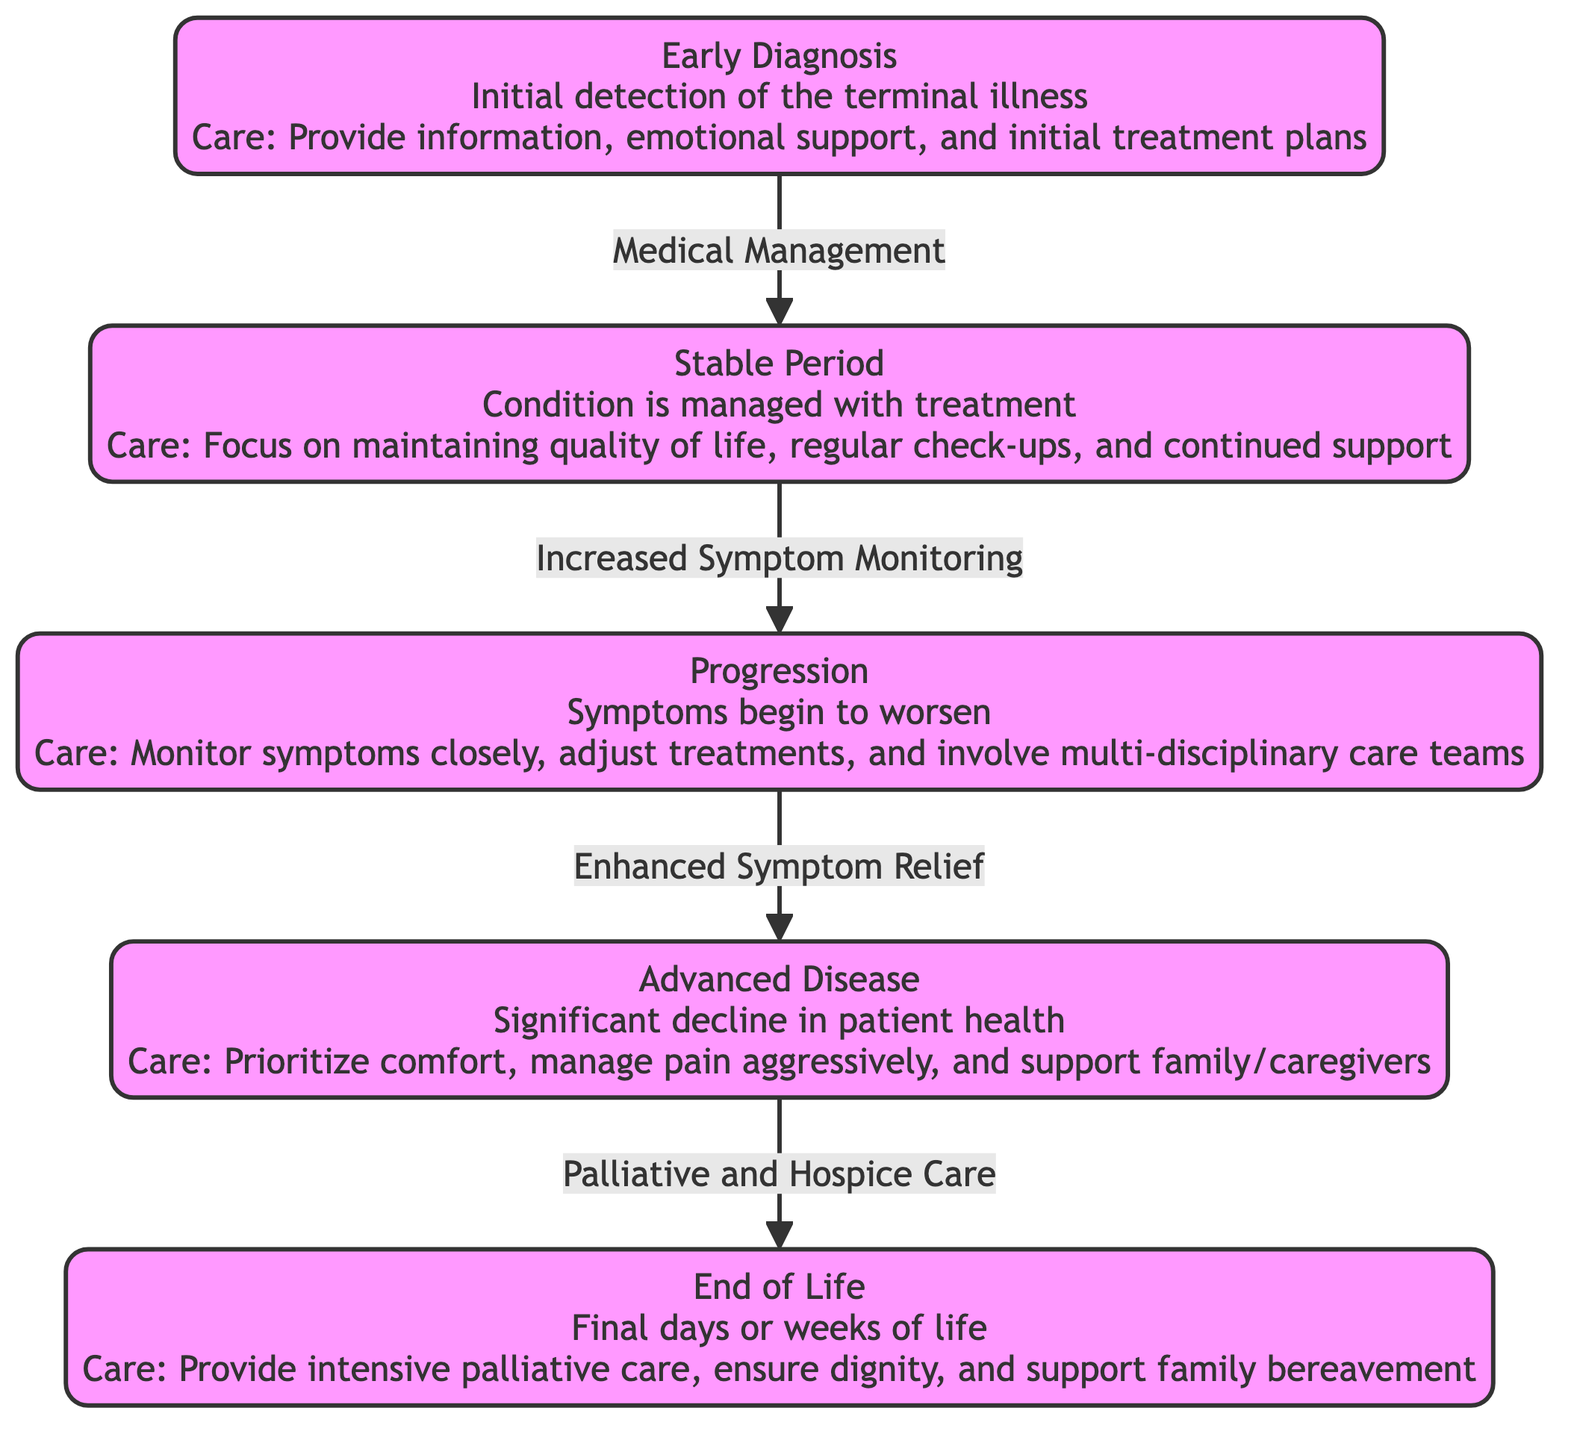What is the first stage in the disease progression timeline? The diagram clearly shows that the first stage is labeled as "Early Diagnosis," which is the initial detection of the terminal illness.
Answer: Early Diagnosis How many stages are presented in the diagram? By counting the distinct stages in the diagram, there are five stages: Early Diagnosis, Stable Period, Progression, Advanced Disease, and End of Life.
Answer: 5 What type of care is provided during the Advanced Disease stage? The diagram specifies that during the Advanced Disease stage, the care focuses on prioritizing comfort and managing pain aggressively.
Answer: Prioritize comfort, manage pain aggressively What is the relationship between the Stable Period and the Progression stage? The diagram indicates a transition from Stable Period to Progression marked by "Increased Symptom Monitoring," which implies that as symptoms are monitored more closely, the patient may enter the Progression phase.
Answer: Increased Symptom Monitoring What care guidance is provided at the End of Life stage? The diagram details that at the End of Life stage, the care involves providing intensive palliative care, ensuring dignity, and supporting family bereavement.
Answer: Intensive palliative care, ensure dignity, support family bereavement Which stage comes after Progression? The flowchart indicates that the stage following Progression is the Advanced Disease stage, which is a significant decline in patient health.
Answer: Advanced Disease What is the main focus during the Stable Period? According to the diagram, the main focus during the Stable Period is on maintaining quality of life, regular check-ups, and continued support.
Answer: Maintain quality of life, regular check-ups, continued support During which stage is there a major focus on symptom relief? The diagram highlights that enhanced symptom relief is a key aspect of the care provided during the transition from Progression to Advanced Disease.
Answer: Advanced Disease 